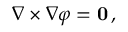<formula> <loc_0><loc_0><loc_500><loc_500>\nabla \times \nabla \varphi = 0 \, ,</formula> 